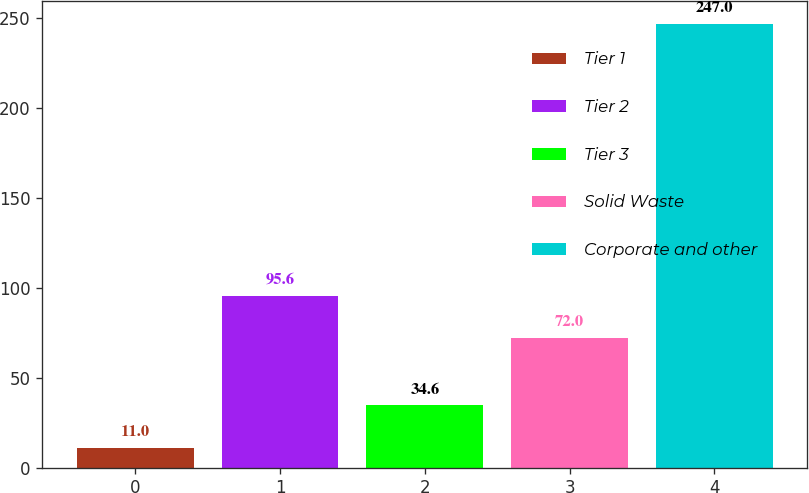<chart> <loc_0><loc_0><loc_500><loc_500><bar_chart><fcel>Tier 1<fcel>Tier 2<fcel>Tier 3<fcel>Solid Waste<fcel>Corporate and other<nl><fcel>11<fcel>95.6<fcel>34.6<fcel>72<fcel>247<nl></chart> 